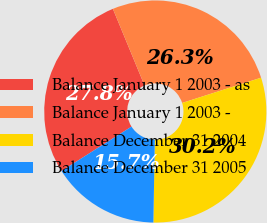Convert chart. <chart><loc_0><loc_0><loc_500><loc_500><pie_chart><fcel>Balance January 1 2003 - as<fcel>Balance January 1 2003 -<fcel>Balance December 31 2004<fcel>Balance December 31 2005<nl><fcel>27.76%<fcel>26.31%<fcel>30.2%<fcel>15.73%<nl></chart> 